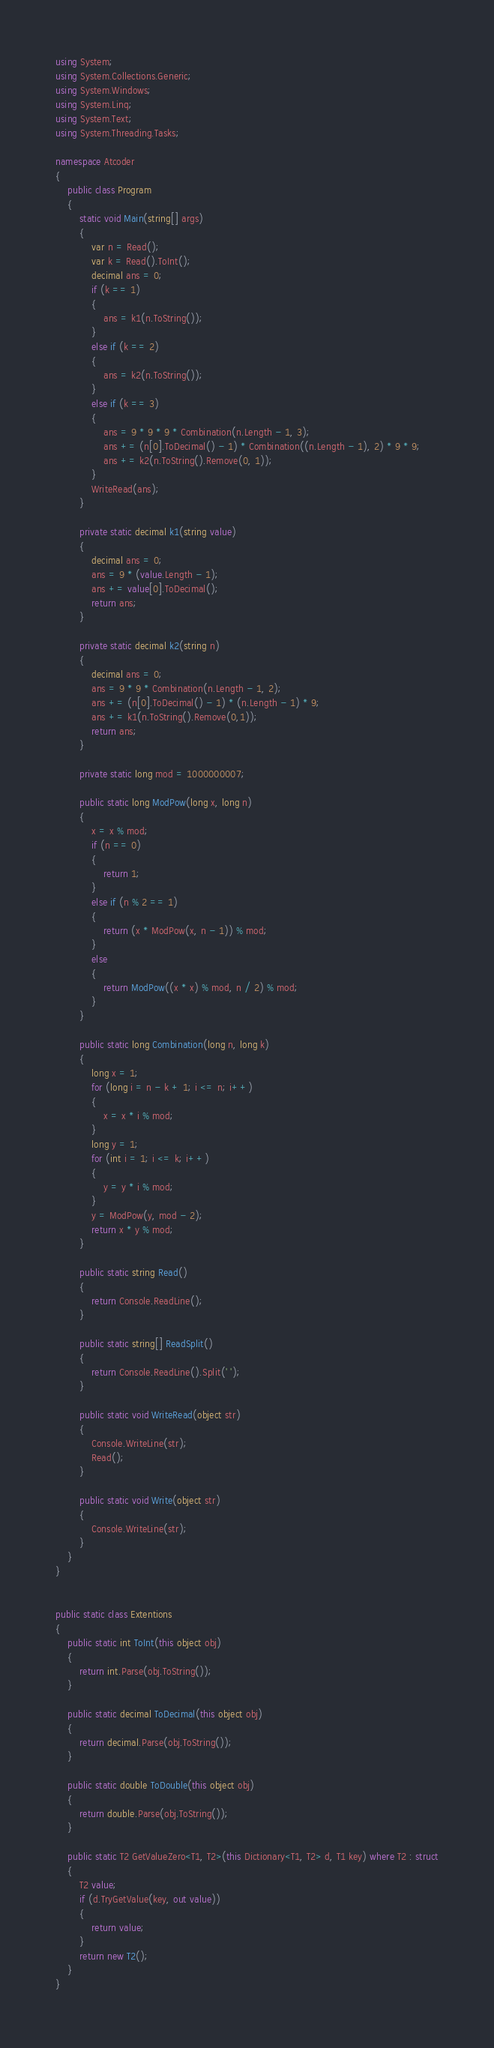Convert code to text. <code><loc_0><loc_0><loc_500><loc_500><_C#_>using System;
using System.Collections.Generic;
using System.Windows;
using System.Linq;
using System.Text;
using System.Threading.Tasks;

namespace Atcoder
{
    public class Program
    {
        static void Main(string[] args)
        {
            var n = Read();
            var k = Read().ToInt();
            decimal ans = 0;
            if (k == 1)
            {
                ans = k1(n.ToString());
            }
            else if (k == 2)
            {
                ans = k2(n.ToString());
            }
            else if (k == 3)
            {
                ans = 9 * 9 * 9 * Combination(n.Length - 1, 3);
                ans += (n[0].ToDecimal() - 1) * Combination((n.Length - 1), 2) * 9 * 9;
                ans += k2(n.ToString().Remove(0, 1));
            }
            WriteRead(ans);
        }

        private static decimal k1(string value)
        {
            decimal ans = 0;
            ans = 9 * (value.Length - 1);
            ans += value[0].ToDecimal();
            return ans;
        }

        private static decimal k2(string n)
        {
            decimal ans = 0;
            ans = 9 * 9 * Combination(n.Length - 1, 2);
            ans += (n[0].ToDecimal() - 1) * (n.Length - 1) * 9;
            ans += k1(n.ToString().Remove(0,1));
            return ans;
        }

        private static long mod = 1000000007;

        public static long ModPow(long x, long n)
        {
            x = x % mod;
            if (n == 0)
            {
                return 1;
            }
            else if (n % 2 == 1)
            {
                return (x * ModPow(x, n - 1)) % mod;
            }
            else
            {
                return ModPow((x * x) % mod, n / 2) % mod;
            }
        }

        public static long Combination(long n, long k)
        {
            long x = 1;
            for (long i = n - k + 1; i <= n; i++)
            {
                x = x * i % mod;
            }
            long y = 1;
            for (int i = 1; i <= k; i++)
            {
                y = y * i % mod;
            }
            y = ModPow(y, mod - 2);
            return x * y % mod;
        }

        public static string Read()
        {
            return Console.ReadLine();
        }

        public static string[] ReadSplit()
        {
            return Console.ReadLine().Split(' ');
        }

        public static void WriteRead(object str)
        {
            Console.WriteLine(str);
            Read();
        }

        public static void Write(object str)
        {
            Console.WriteLine(str);
        }
    }
}


public static class Extentions
{
    public static int ToInt(this object obj)
    {
        return int.Parse(obj.ToString());
    }

    public static decimal ToDecimal(this object obj)
    {
        return decimal.Parse(obj.ToString());
    }

    public static double ToDouble(this object obj)
    {
        return double.Parse(obj.ToString());
    }

    public static T2 GetValueZero<T1, T2>(this Dictionary<T1, T2> d, T1 key) where T2 : struct
    {
        T2 value;
        if (d.TryGetValue(key, out value))
        {
            return value;
        }
        return new T2();
    }
}

</code> 